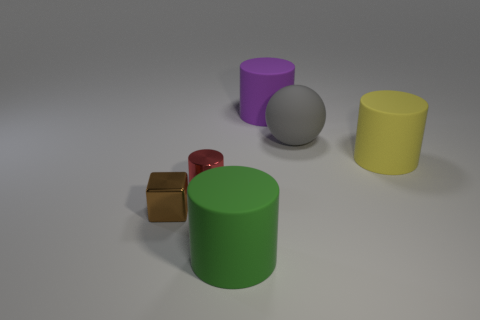Subtract all brown cylinders. Subtract all purple cubes. How many cylinders are left? 4 Add 3 green matte cylinders. How many objects exist? 9 Subtract all cubes. How many objects are left? 5 Add 5 tiny metal cylinders. How many tiny metal cylinders are left? 6 Add 5 tiny yellow metal cylinders. How many tiny yellow metal cylinders exist? 5 Subtract 0 purple blocks. How many objects are left? 6 Subtract all tiny brown blocks. Subtract all large purple matte cylinders. How many objects are left? 4 